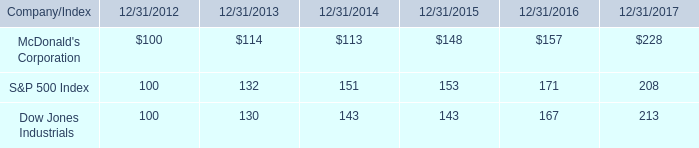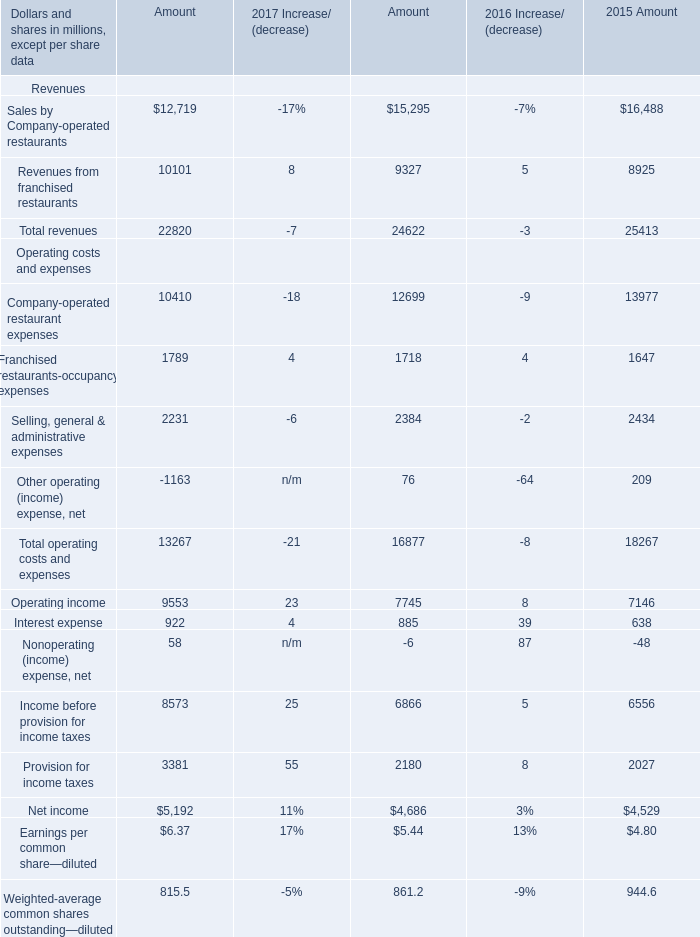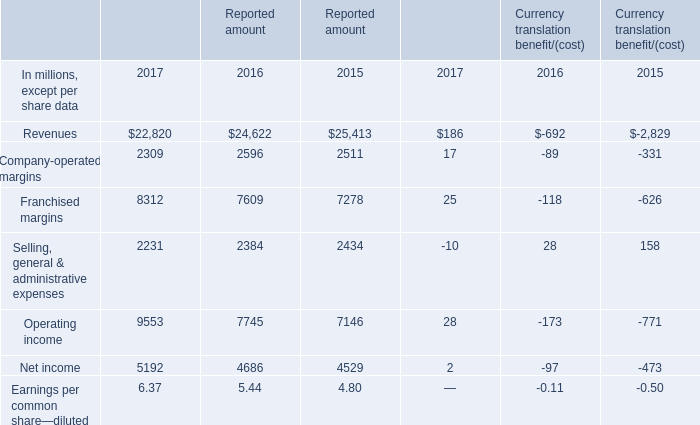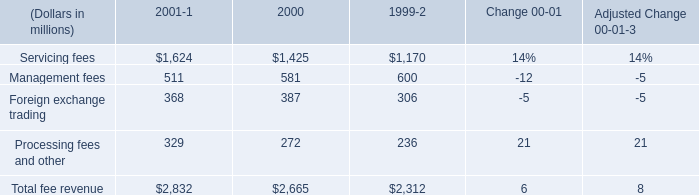What was the average of Company-operated restaurant expenses in 2017, 2016, and 2015? (in million) 
Computations: (((10410 + 12699) + 13977) / 3)
Answer: 12362.0. 